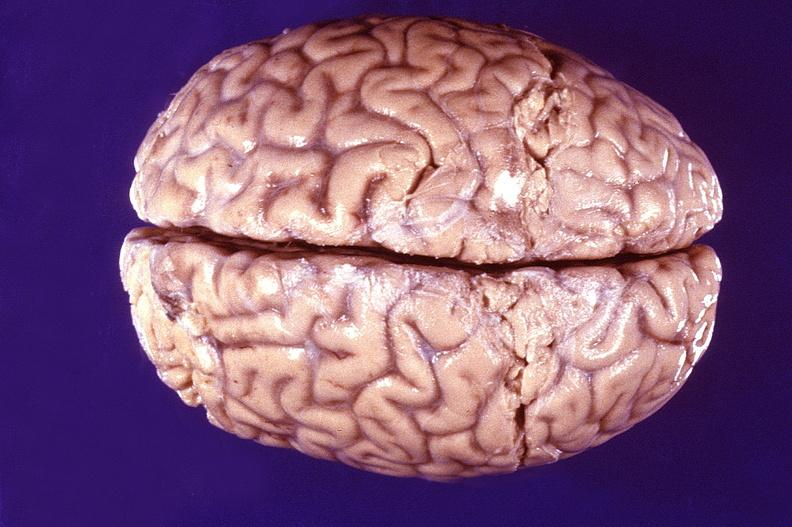what does this image show?
Answer the question using a single word or phrase. Normal brain 